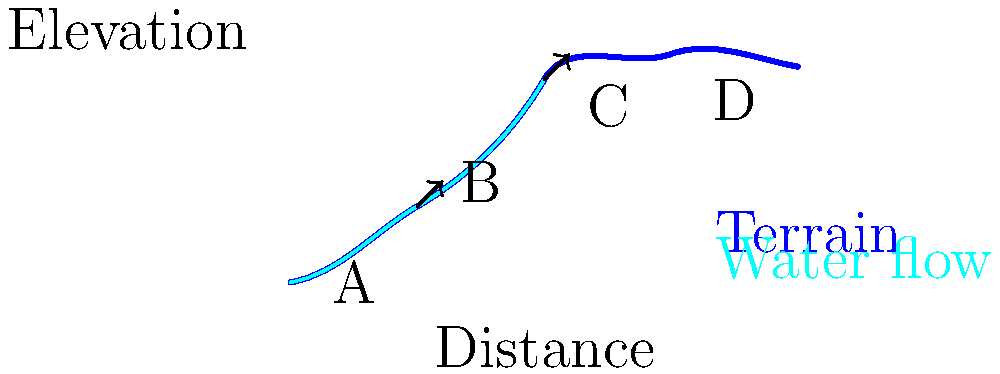In the watershed topography shown above, at which point is the water flow likely to be the slowest, and how might this impact sediment deposition from logging activities upstream? To answer this question, we need to analyze the topography and understand how it affects water flow and sediment deposition:

1. Water flow speed is inversely related to the slope of the terrain. The flatter the terrain, the slower the water flow.

2. Examining the diagram:
   - Point A: Steep slope, fast water flow
   - Point B: Steepest slope, fastest water flow
   - Point C: Slope begins to decrease, water flow starts to slow
   - Point D: Flattest section, slowest water flow

3. The water flow is likely to be slowest at point D due to the relatively flat terrain.

4. Slower water flow impacts sediment deposition in the following ways:
   - As water slows down, it loses energy and can no longer carry as much sediment.
   - This causes sediment to settle out of the water and deposit on the streambed.

5. In the context of logging activities upstream:
   - Logging can increase erosion and sediment load in the water.
   - As this sediment-laden water reaches the flatter area at point D, more sediment will be deposited.
   - This can lead to:
     a) Shallower water depths
     b) Changes in stream channel morphology
     c) Potential impacts on aquatic habitats

6. From a water resource management perspective, this area of slow flow and high deposition (point D) would be a critical point for monitoring and potentially implementing sediment control measures to mitigate the impacts of upstream logging activities.
Answer: Point D; increased sediment deposition due to slower water flow. 